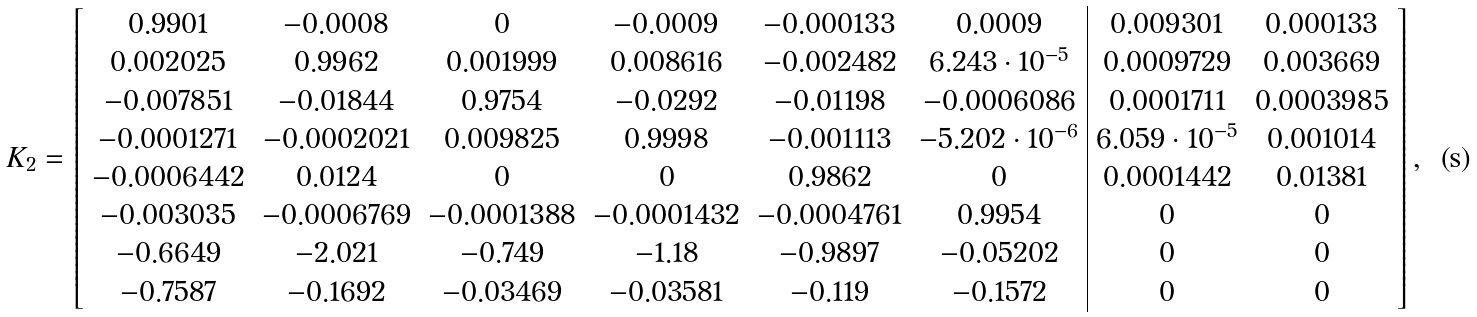<formula> <loc_0><loc_0><loc_500><loc_500>K _ { 2 } = \left [ \begin{array} { c c c c c c | c c } 0 . 9 9 0 1 & - 0 . 0 0 0 8 & 0 & - 0 . 0 0 0 9 & - 0 . 0 0 0 1 3 3 & 0 . 0 0 0 9 & 0 . 0 0 9 3 0 1 & 0 . 0 0 0 1 3 3 \\ 0 . 0 0 2 0 2 5 & 0 . 9 9 6 2 & 0 . 0 0 1 9 9 9 & 0 . 0 0 8 6 1 6 & - 0 . 0 0 2 4 8 2 & 6 . 2 4 3 \cdot 1 0 ^ { - 5 } & 0 . 0 0 0 9 7 2 9 & 0 . 0 0 3 6 6 9 \\ - 0 . 0 0 7 8 5 1 & - 0 . 0 1 8 4 4 & 0 . 9 7 5 4 & - 0 . 0 2 9 2 & - 0 . 0 1 1 9 8 & - 0 . 0 0 0 6 0 8 6 & 0 . 0 0 0 1 7 1 1 & 0 . 0 0 0 3 9 8 5 \\ - 0 . 0 0 0 1 2 7 1 & - 0 . 0 0 0 2 0 2 1 & 0 . 0 0 9 8 2 5 & 0 . 9 9 9 8 & - 0 . 0 0 1 1 1 3 & - 5 . 2 0 2 \cdot 1 0 ^ { - 6 } & 6 . 0 5 9 \cdot 1 0 ^ { - 5 } & 0 . 0 0 1 0 1 4 \\ - 0 . 0 0 0 6 4 4 2 & 0 . 0 1 2 4 & 0 & 0 & 0 . 9 8 6 2 & 0 & 0 . 0 0 0 1 4 4 2 & 0 . 0 1 3 8 1 \\ - 0 . 0 0 3 0 3 5 & - 0 . 0 0 0 6 7 6 9 & - 0 . 0 0 0 1 3 8 8 & - 0 . 0 0 0 1 4 3 2 & - 0 . 0 0 0 4 7 6 1 & 0 . 9 9 5 4 & 0 & 0 \\ - 0 . 6 6 4 9 & - 2 . 0 2 1 & - 0 . 7 4 9 & - 1 . 1 8 & - 0 . 9 8 9 7 & - 0 . 0 5 2 0 2 & 0 & 0 \\ - 0 . 7 5 8 7 & - 0 . 1 6 9 2 & - 0 . 0 3 4 6 9 & - 0 . 0 3 5 8 1 & - 0 . 1 1 9 & - 0 . 1 5 7 2 & 0 & 0 \end{array} \right ] ,</formula> 